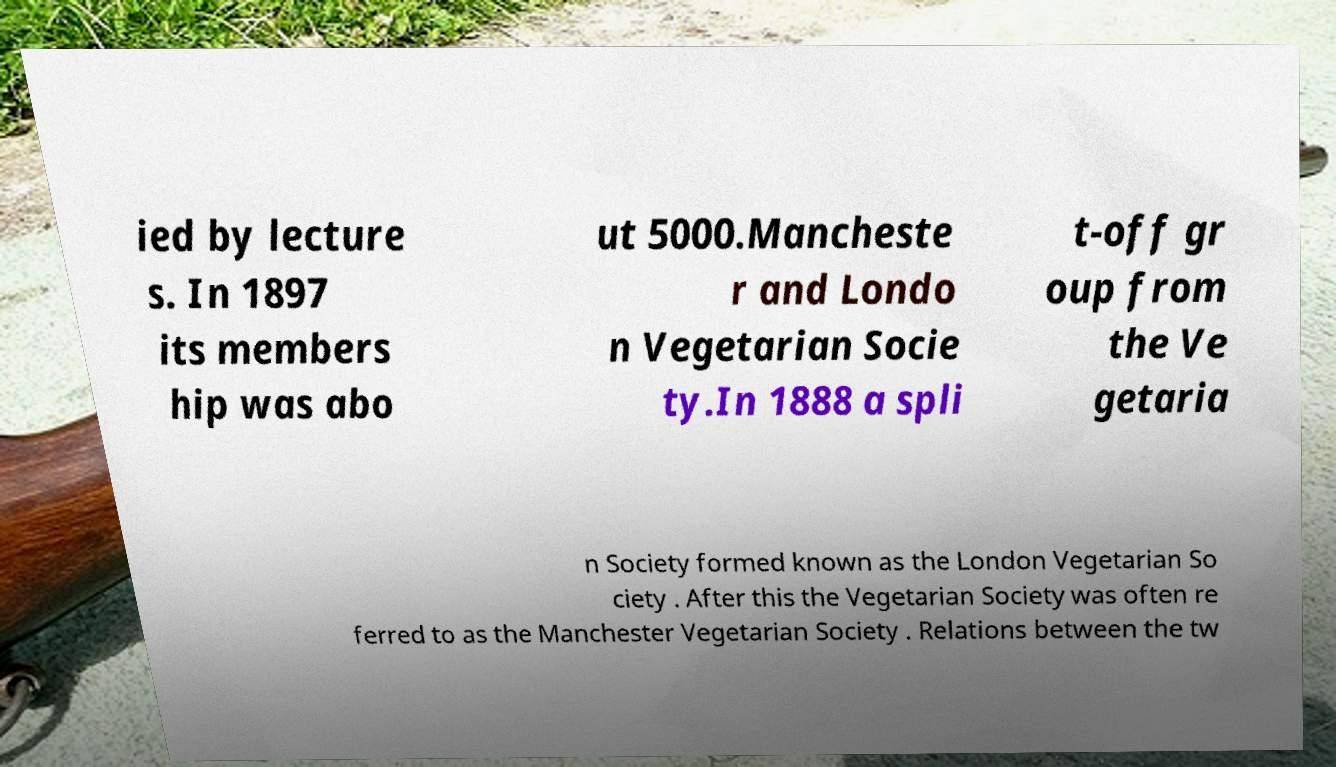For documentation purposes, I need the text within this image transcribed. Could you provide that? ied by lecture s. In 1897 its members hip was abo ut 5000.Mancheste r and Londo n Vegetarian Socie ty.In 1888 a spli t-off gr oup from the Ve getaria n Society formed known as the London Vegetarian So ciety . After this the Vegetarian Society was often re ferred to as the Manchester Vegetarian Society . Relations between the tw 